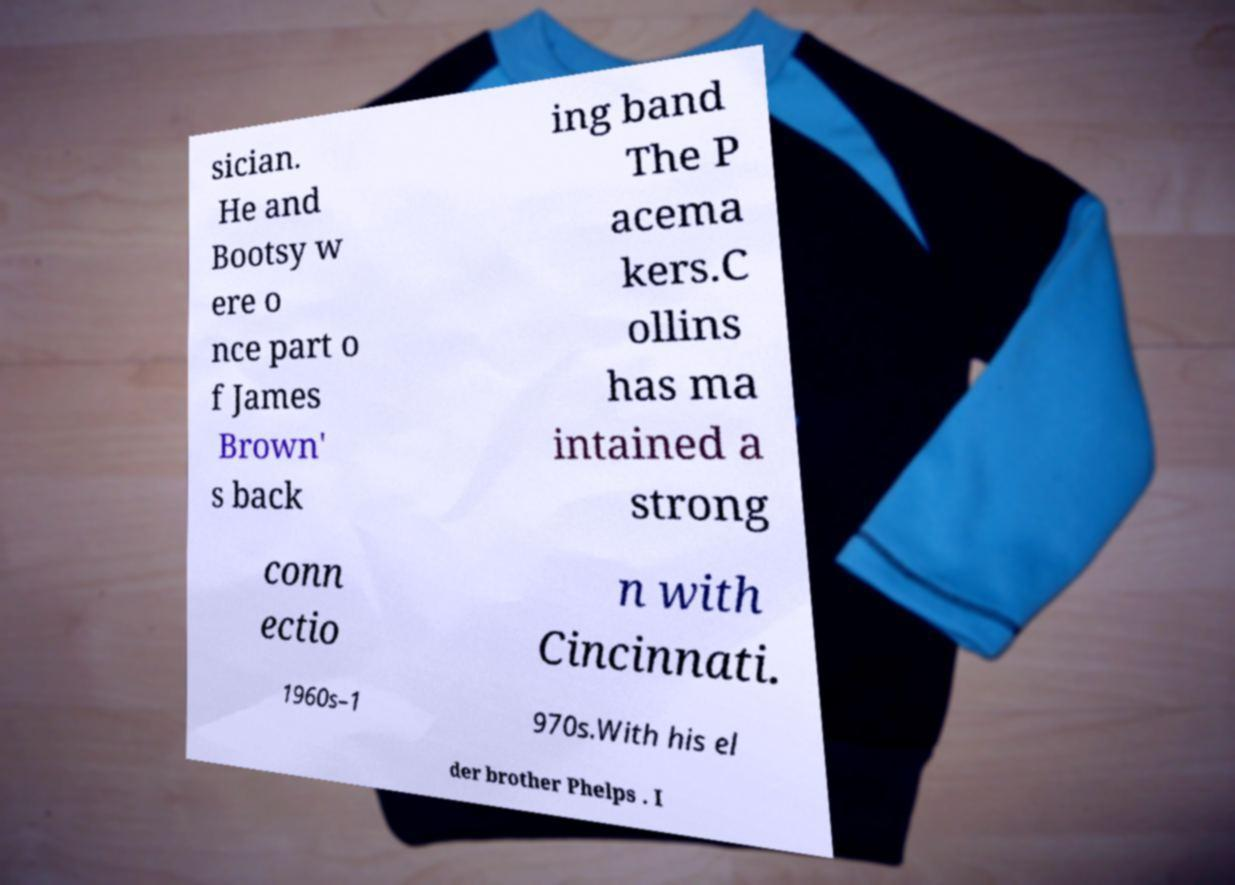Can you read and provide the text displayed in the image?This photo seems to have some interesting text. Can you extract and type it out for me? sician. He and Bootsy w ere o nce part o f James Brown' s back ing band The P acema kers.C ollins has ma intained a strong conn ectio n with Cincinnati. 1960s–1 970s.With his el der brother Phelps . I 